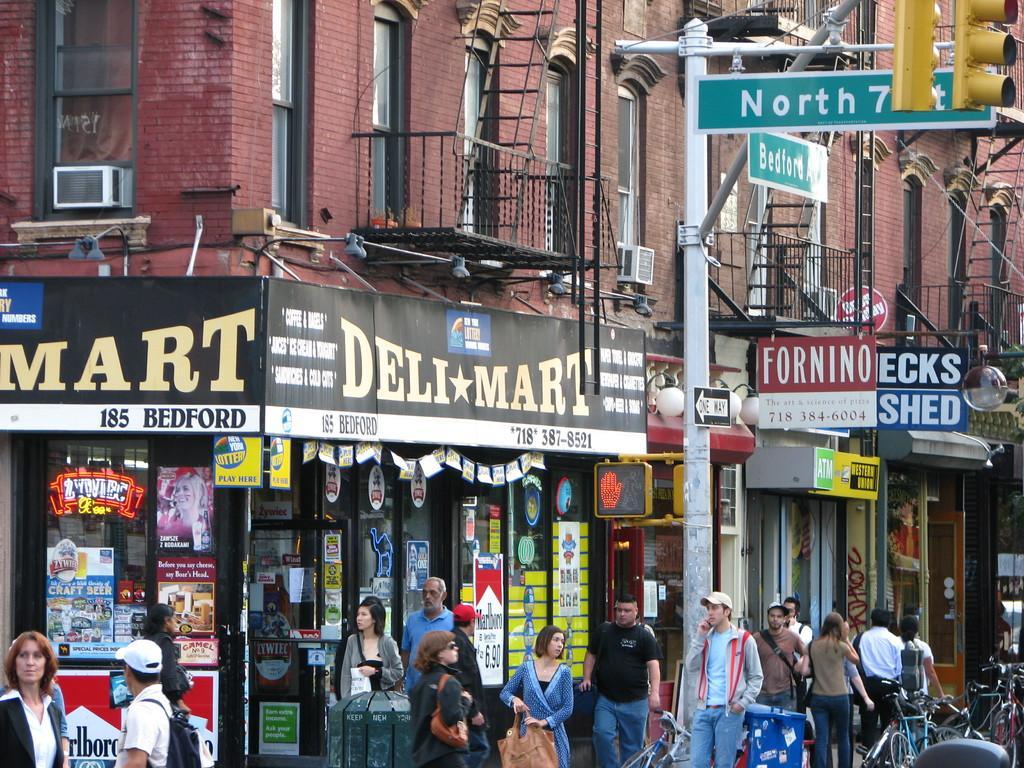In one or two sentences, can you explain what this image depicts? The picture is clicked on a road. There are many people walking on the sidewalk. There are cycles parked here. In the background there are buildings. This is a traffic signal. These are shops. There are hoardings, banner over here. 